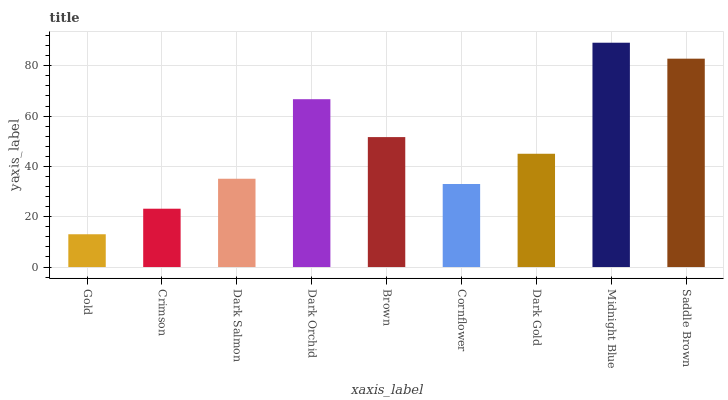Is Gold the minimum?
Answer yes or no. Yes. Is Midnight Blue the maximum?
Answer yes or no. Yes. Is Crimson the minimum?
Answer yes or no. No. Is Crimson the maximum?
Answer yes or no. No. Is Crimson greater than Gold?
Answer yes or no. Yes. Is Gold less than Crimson?
Answer yes or no. Yes. Is Gold greater than Crimson?
Answer yes or no. No. Is Crimson less than Gold?
Answer yes or no. No. Is Dark Gold the high median?
Answer yes or no. Yes. Is Dark Gold the low median?
Answer yes or no. Yes. Is Dark Orchid the high median?
Answer yes or no. No. Is Gold the low median?
Answer yes or no. No. 